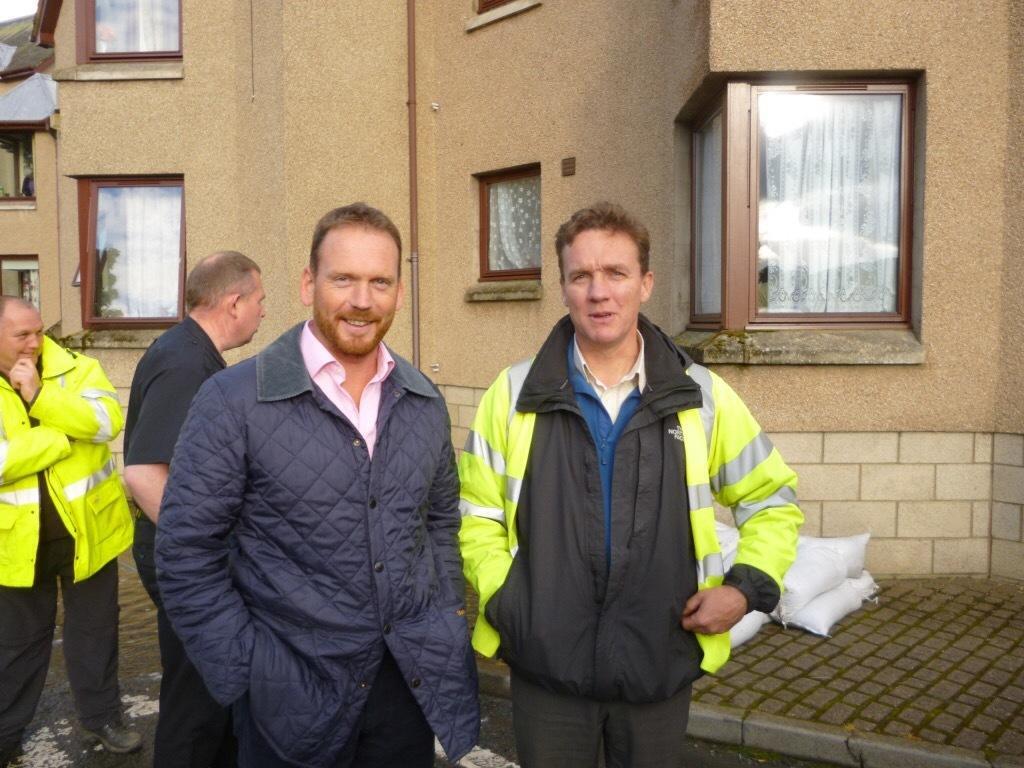How would you summarize this image in a sentence or two? In this image we can see one building with glass windows, some curtains attached to the windows, some objects on the floor, one pipe attached to the wall and some people standing on the road. 